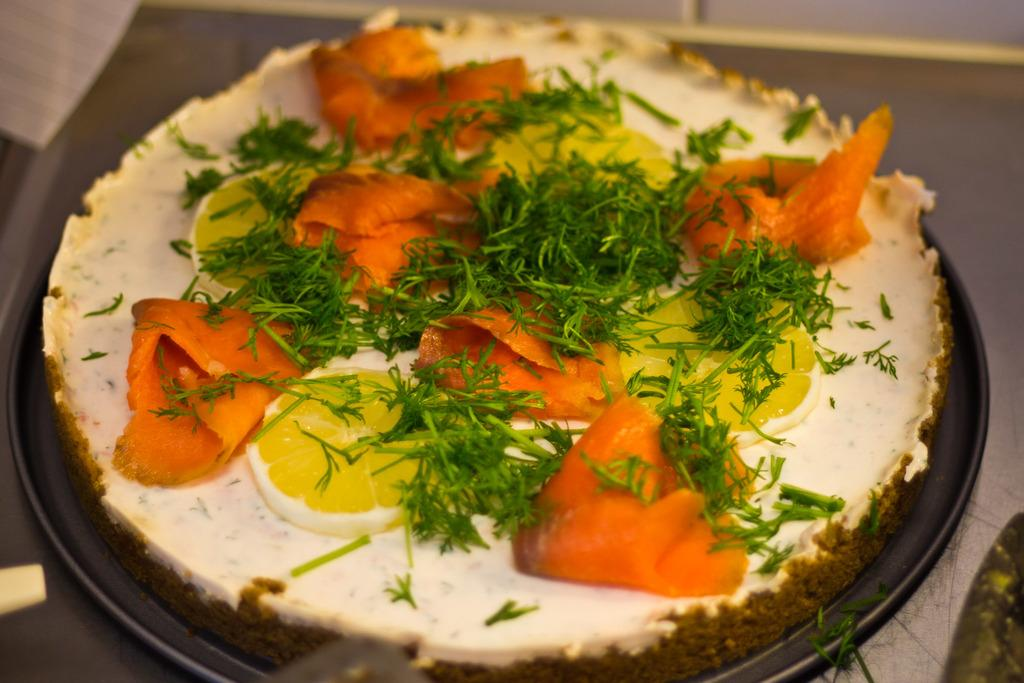What is the main object in the image? There is a pan in the image. What is inside the pan? The pan contains a food item. How is the food item decorated? The food item is garnished with leaves and lemon slices. Can you describe the background of the image? The background of the image is blurred. What type of card is being used to stir the food in the pan? There is no card present in the image, and the food is not being stirred. 